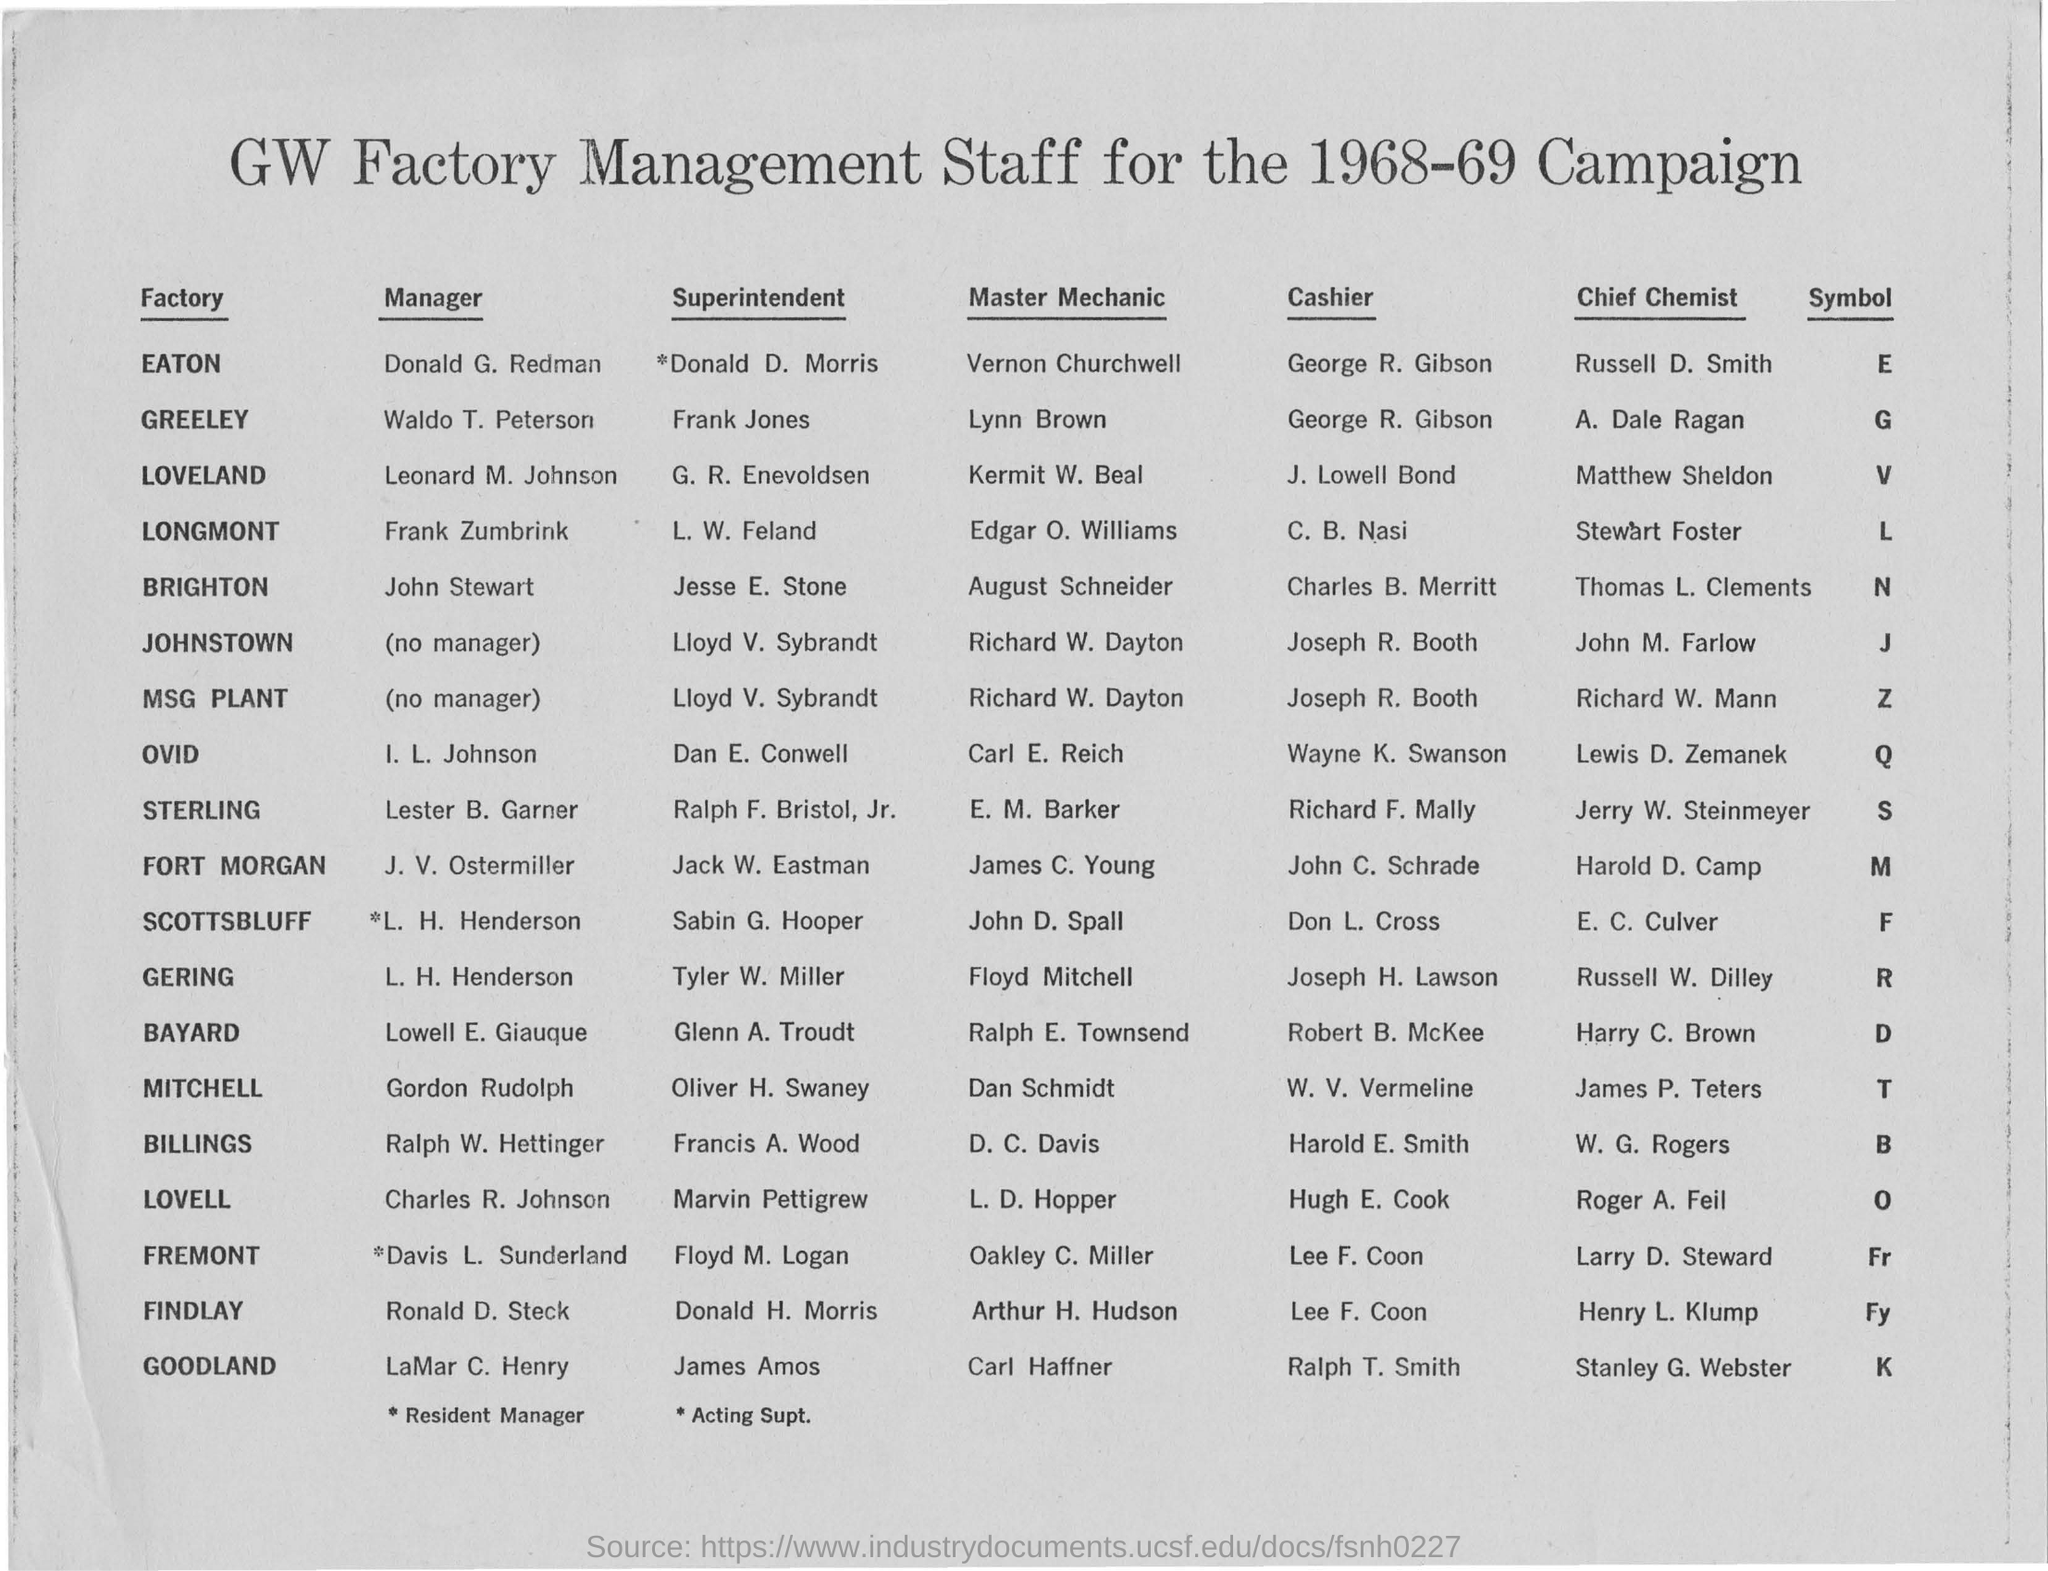Mention a couple of crucial points in this snapshot. The symbol for an MSG plant is Z.. The campaign was held in the years 1968-69. The cashier for Findlay factory is named LEE F. COON. The name of the manager at the Eaton factory is Donald G. Redman. 